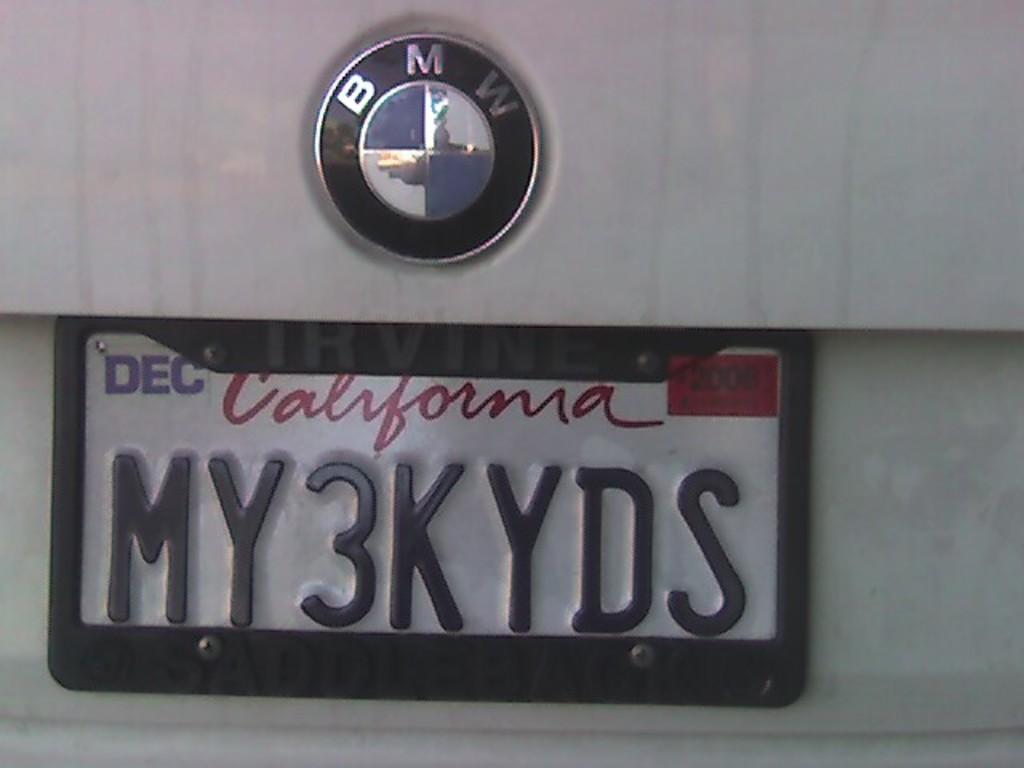What state is the license plate?
Make the answer very short. California. What does license plate number read?
Ensure brevity in your answer.  My3kyds. 